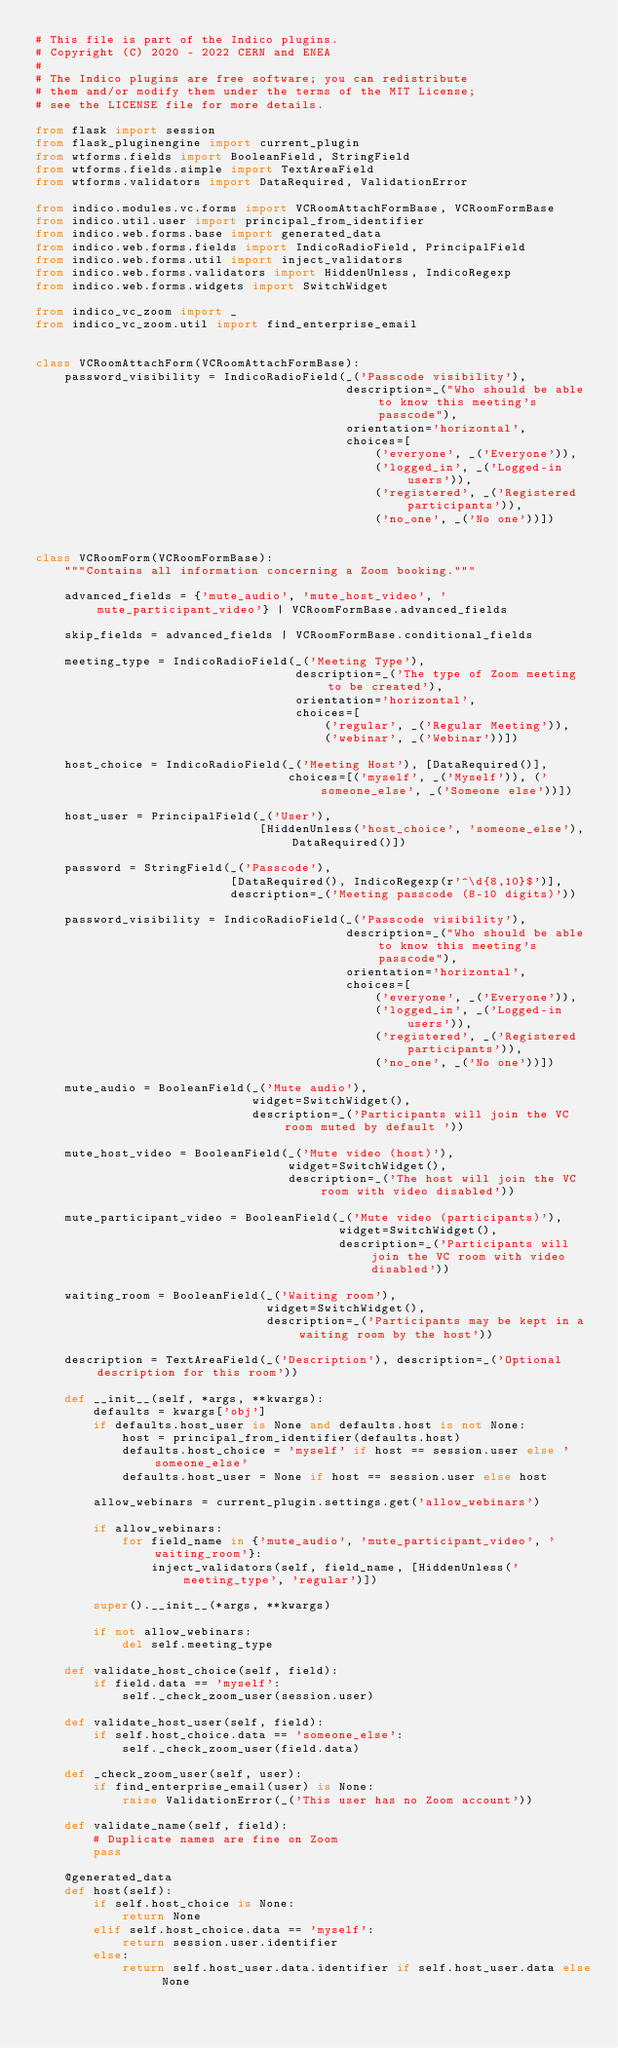Convert code to text. <code><loc_0><loc_0><loc_500><loc_500><_Python_># This file is part of the Indico plugins.
# Copyright (C) 2020 - 2022 CERN and ENEA
#
# The Indico plugins are free software; you can redistribute
# them and/or modify them under the terms of the MIT License;
# see the LICENSE file for more details.

from flask import session
from flask_pluginengine import current_plugin
from wtforms.fields import BooleanField, StringField
from wtforms.fields.simple import TextAreaField
from wtforms.validators import DataRequired, ValidationError

from indico.modules.vc.forms import VCRoomAttachFormBase, VCRoomFormBase
from indico.util.user import principal_from_identifier
from indico.web.forms.base import generated_data
from indico.web.forms.fields import IndicoRadioField, PrincipalField
from indico.web.forms.util import inject_validators
from indico.web.forms.validators import HiddenUnless, IndicoRegexp
from indico.web.forms.widgets import SwitchWidget

from indico_vc_zoom import _
from indico_vc_zoom.util import find_enterprise_email


class VCRoomAttachForm(VCRoomAttachFormBase):
    password_visibility = IndicoRadioField(_('Passcode visibility'),
                                           description=_("Who should be able to know this meeting's passcode"),
                                           orientation='horizontal',
                                           choices=[
                                               ('everyone', _('Everyone')),
                                               ('logged_in', _('Logged-in users')),
                                               ('registered', _('Registered participants')),
                                               ('no_one', _('No one'))])


class VCRoomForm(VCRoomFormBase):
    """Contains all information concerning a Zoom booking."""

    advanced_fields = {'mute_audio', 'mute_host_video', 'mute_participant_video'} | VCRoomFormBase.advanced_fields

    skip_fields = advanced_fields | VCRoomFormBase.conditional_fields

    meeting_type = IndicoRadioField(_('Meeting Type'),
                                    description=_('The type of Zoom meeting to be created'),
                                    orientation='horizontal',
                                    choices=[
                                        ('regular', _('Regular Meeting')),
                                        ('webinar', _('Webinar'))])

    host_choice = IndicoRadioField(_('Meeting Host'), [DataRequired()],
                                   choices=[('myself', _('Myself')), ('someone_else', _('Someone else'))])

    host_user = PrincipalField(_('User'),
                               [HiddenUnless('host_choice', 'someone_else'), DataRequired()])

    password = StringField(_('Passcode'),
                           [DataRequired(), IndicoRegexp(r'^\d{8,10}$')],
                           description=_('Meeting passcode (8-10 digits)'))

    password_visibility = IndicoRadioField(_('Passcode visibility'),
                                           description=_("Who should be able to know this meeting's passcode"),
                                           orientation='horizontal',
                                           choices=[
                                               ('everyone', _('Everyone')),
                                               ('logged_in', _('Logged-in users')),
                                               ('registered', _('Registered participants')),
                                               ('no_one', _('No one'))])

    mute_audio = BooleanField(_('Mute audio'),
                              widget=SwitchWidget(),
                              description=_('Participants will join the VC room muted by default '))

    mute_host_video = BooleanField(_('Mute video (host)'),
                                   widget=SwitchWidget(),
                                   description=_('The host will join the VC room with video disabled'))

    mute_participant_video = BooleanField(_('Mute video (participants)'),
                                          widget=SwitchWidget(),
                                          description=_('Participants will join the VC room with video disabled'))

    waiting_room = BooleanField(_('Waiting room'),
                                widget=SwitchWidget(),
                                description=_('Participants may be kept in a waiting room by the host'))

    description = TextAreaField(_('Description'), description=_('Optional description for this room'))

    def __init__(self, *args, **kwargs):
        defaults = kwargs['obj']
        if defaults.host_user is None and defaults.host is not None:
            host = principal_from_identifier(defaults.host)
            defaults.host_choice = 'myself' if host == session.user else 'someone_else'
            defaults.host_user = None if host == session.user else host

        allow_webinars = current_plugin.settings.get('allow_webinars')

        if allow_webinars:
            for field_name in {'mute_audio', 'mute_participant_video', 'waiting_room'}:
                inject_validators(self, field_name, [HiddenUnless('meeting_type', 'regular')])

        super().__init__(*args, **kwargs)

        if not allow_webinars:
            del self.meeting_type

    def validate_host_choice(self, field):
        if field.data == 'myself':
            self._check_zoom_user(session.user)

    def validate_host_user(self, field):
        if self.host_choice.data == 'someone_else':
            self._check_zoom_user(field.data)

    def _check_zoom_user(self, user):
        if find_enterprise_email(user) is None:
            raise ValidationError(_('This user has no Zoom account'))

    def validate_name(self, field):
        # Duplicate names are fine on Zoom
        pass

    @generated_data
    def host(self):
        if self.host_choice is None:
            return None
        elif self.host_choice.data == 'myself':
            return session.user.identifier
        else:
            return self.host_user.data.identifier if self.host_user.data else None
</code> 